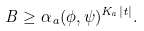<formula> <loc_0><loc_0><loc_500><loc_500>B \geq \alpha _ { a } ( \phi , \psi ) ^ { K _ { a } | t | } .</formula> 